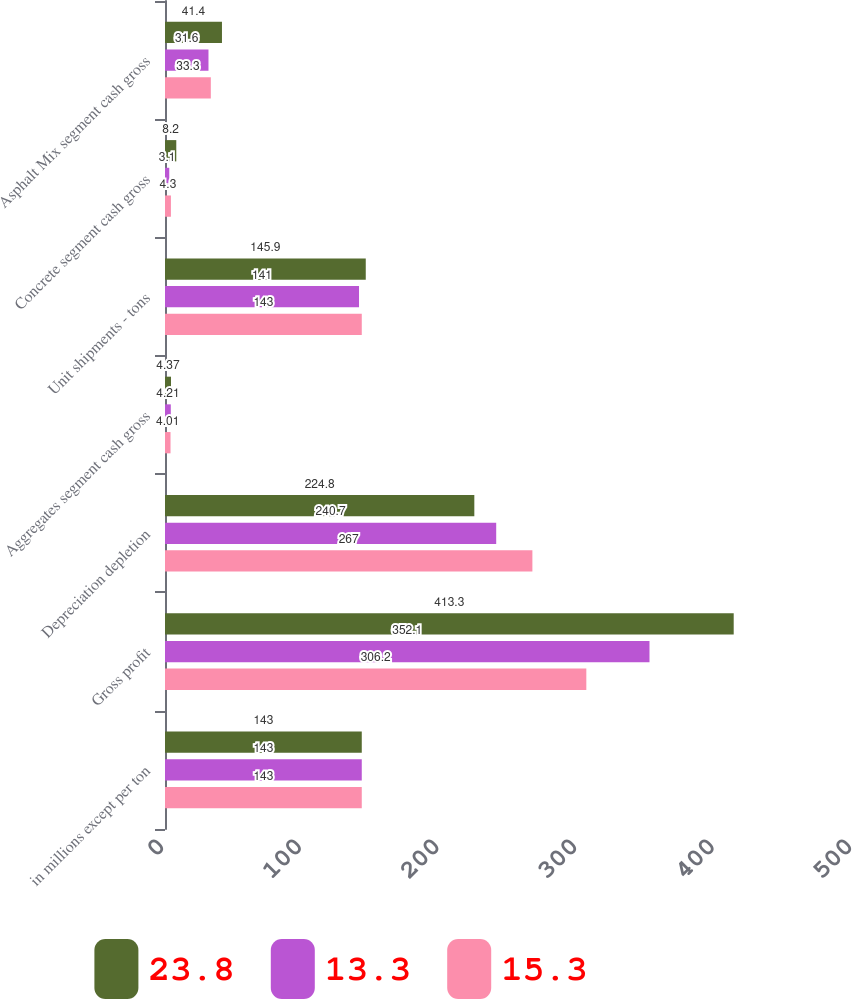Convert chart. <chart><loc_0><loc_0><loc_500><loc_500><stacked_bar_chart><ecel><fcel>in millions except per ton<fcel>Gross profit<fcel>Depreciation depletion<fcel>Aggregates segment cash gross<fcel>Unit shipments - tons<fcel>Concrete segment cash gross<fcel>Asphalt Mix segment cash gross<nl><fcel>23.8<fcel>143<fcel>413.3<fcel>224.8<fcel>4.37<fcel>145.9<fcel>8.2<fcel>41.4<nl><fcel>13.3<fcel>143<fcel>352.1<fcel>240.7<fcel>4.21<fcel>141<fcel>3.1<fcel>31.6<nl><fcel>15.3<fcel>143<fcel>306.2<fcel>267<fcel>4.01<fcel>143<fcel>4.3<fcel>33.3<nl></chart> 